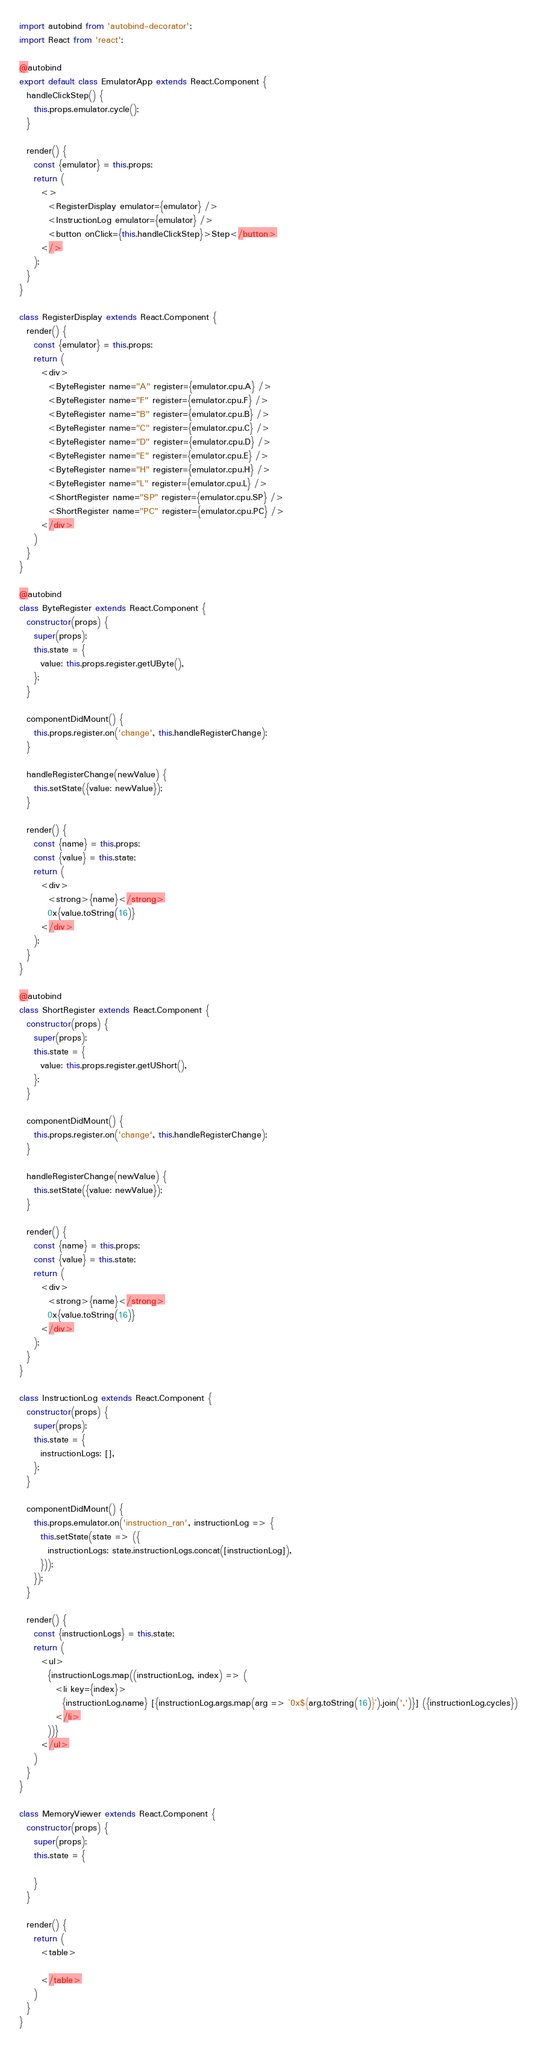<code> <loc_0><loc_0><loc_500><loc_500><_JavaScript_>import autobind from 'autobind-decorator';
import React from 'react';

@autobind
export default class EmulatorApp extends React.Component {
  handleClickStep() {
    this.props.emulator.cycle();
  }

  render() {
    const {emulator} = this.props;
    return (
      <>
        <RegisterDisplay emulator={emulator} />
        <InstructionLog emulator={emulator} />
        <button onClick={this.handleClickStep}>Step</button>
      </>
    );
  }
}

class RegisterDisplay extends React.Component {
  render() {
    const {emulator} = this.props;
    return (
      <div>
        <ByteRegister name="A" register={emulator.cpu.A} />
        <ByteRegister name="F" register={emulator.cpu.F} />
        <ByteRegister name="B" register={emulator.cpu.B} />
        <ByteRegister name="C" register={emulator.cpu.C} />
        <ByteRegister name="D" register={emulator.cpu.D} />
        <ByteRegister name="E" register={emulator.cpu.E} />
        <ByteRegister name="H" register={emulator.cpu.H} />
        <ByteRegister name="L" register={emulator.cpu.L} />
        <ShortRegister name="SP" register={emulator.cpu.SP} />
        <ShortRegister name="PC" register={emulator.cpu.PC} />
      </div>
    )
  }
}

@autobind
class ByteRegister extends React.Component {
  constructor(props) {
    super(props);
    this.state = {
      value: this.props.register.getUByte(),
    };
  }

  componentDidMount() {
    this.props.register.on('change', this.handleRegisterChange);
  }

  handleRegisterChange(newValue) {
    this.setState({value: newValue});
  }

  render() {
    const {name} = this.props;
    const {value} = this.state;
    return (
      <div>
        <strong>{name}</strong>
        0x{value.toString(16)}
      </div>
    );
  }
}

@autobind
class ShortRegister extends React.Component {
  constructor(props) {
    super(props);
    this.state = {
      value: this.props.register.getUShort(),
    };
  }

  componentDidMount() {
    this.props.register.on('change', this.handleRegisterChange);
  }

  handleRegisterChange(newValue) {
    this.setState({value: newValue});
  }

  render() {
    const {name} = this.props;
    const {value} = this.state;
    return (
      <div>
        <strong>{name}</strong>
        0x{value.toString(16)}
      </div>
    );
  }
}

class InstructionLog extends React.Component {
  constructor(props) {
    super(props);
    this.state = {
      instructionLogs: [],
    };
  }

  componentDidMount() {
    this.props.emulator.on('instruction_ran', instructionLog => {
      this.setState(state => ({
        instructionLogs: state.instructionLogs.concat([instructionLog]),
      }));
    });
  }

  render() {
    const {instructionLogs} = this.state;
    return (
      <ul>
        {instructionLogs.map((instructionLog, index) => (
          <li key={index}>
            {instructionLog.name} [{instructionLog.args.map(arg => `0x${arg.toString(16)}`).join(',')}] ({instructionLog.cycles})
          </li>
        ))}
      </ul>
    )
  }
}

class MemoryViewer extends React.Component {
  constructor(props) {
    super(props);
    this.state = {

    }
  }

  render() {
    return (
      <table>

      </table>
    )
  }
}
</code> 